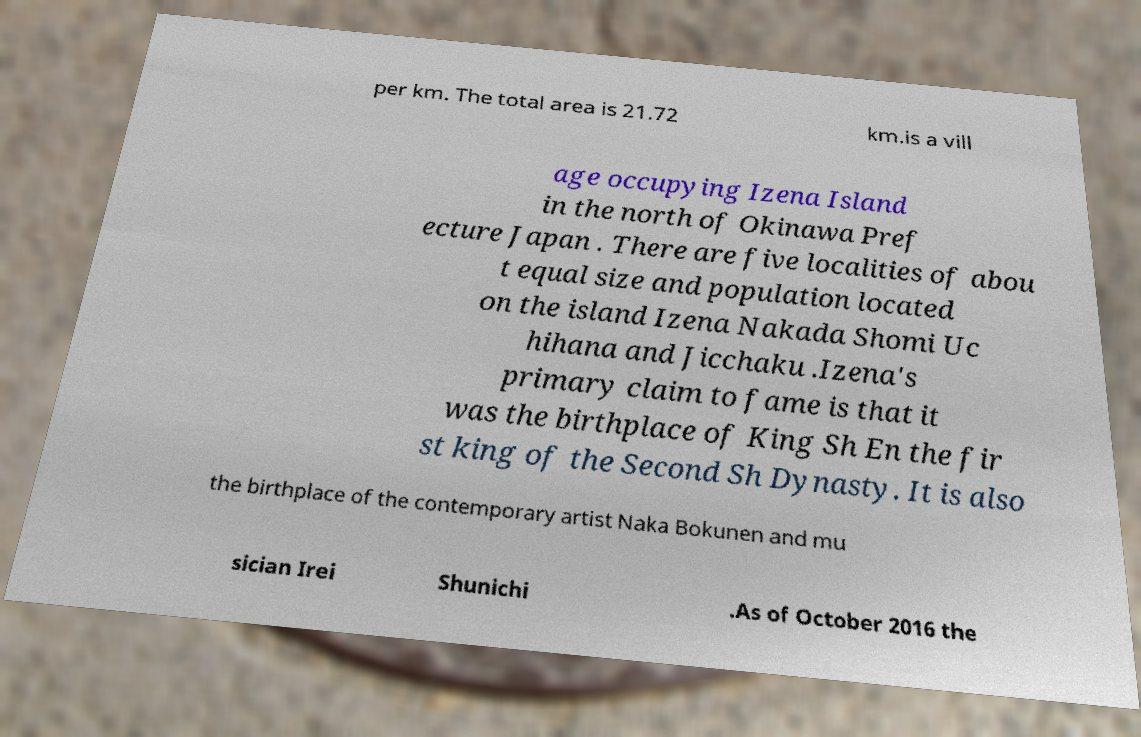For documentation purposes, I need the text within this image transcribed. Could you provide that? per km. The total area is 21.72 km.is a vill age occupying Izena Island in the north of Okinawa Pref ecture Japan . There are five localities of abou t equal size and population located on the island Izena Nakada Shomi Uc hihana and Jicchaku .Izena's primary claim to fame is that it was the birthplace of King Sh En the fir st king of the Second Sh Dynasty. It is also the birthplace of the contemporary artist Naka Bokunen and mu sician Irei Shunichi .As of October 2016 the 